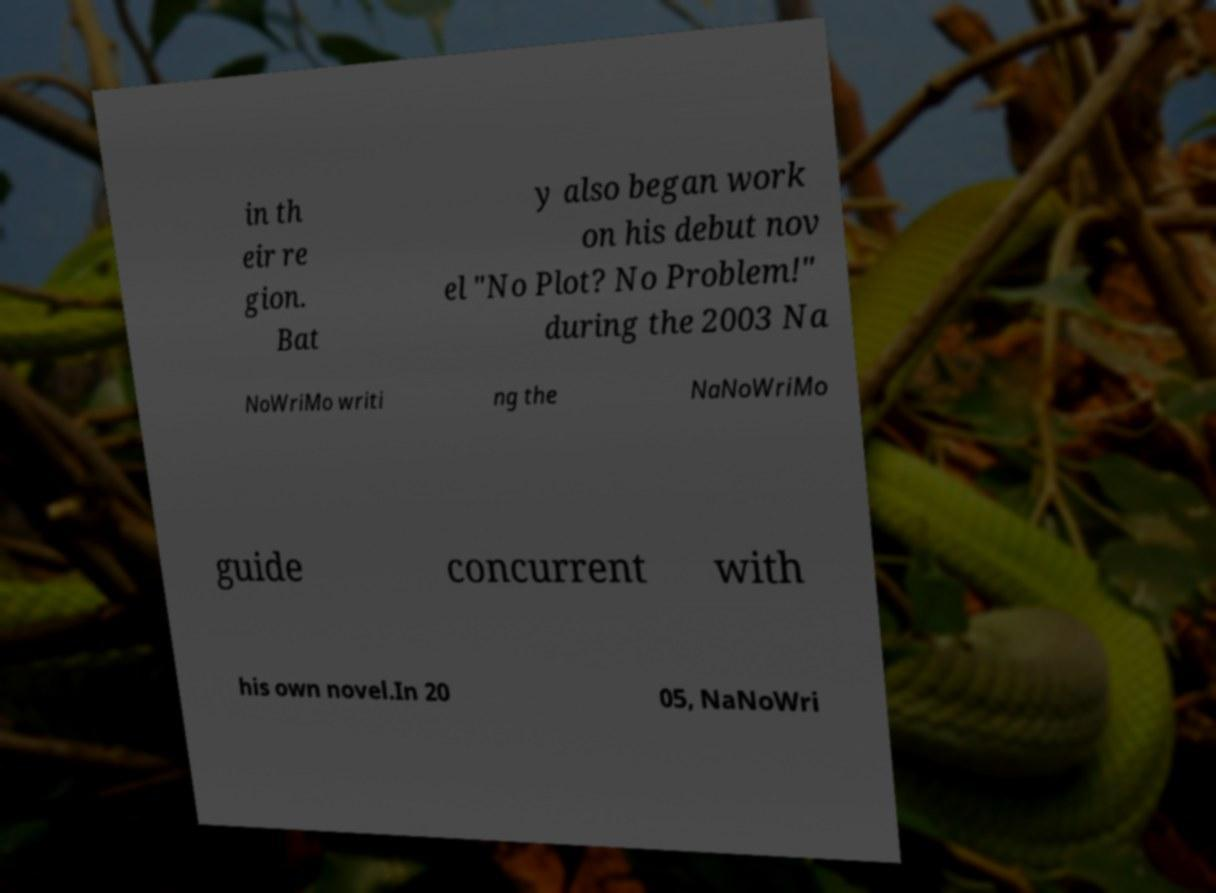Could you extract and type out the text from this image? in th eir re gion. Bat y also began work on his debut nov el "No Plot? No Problem!" during the 2003 Na NoWriMo writi ng the NaNoWriMo guide concurrent with his own novel.In 20 05, NaNoWri 